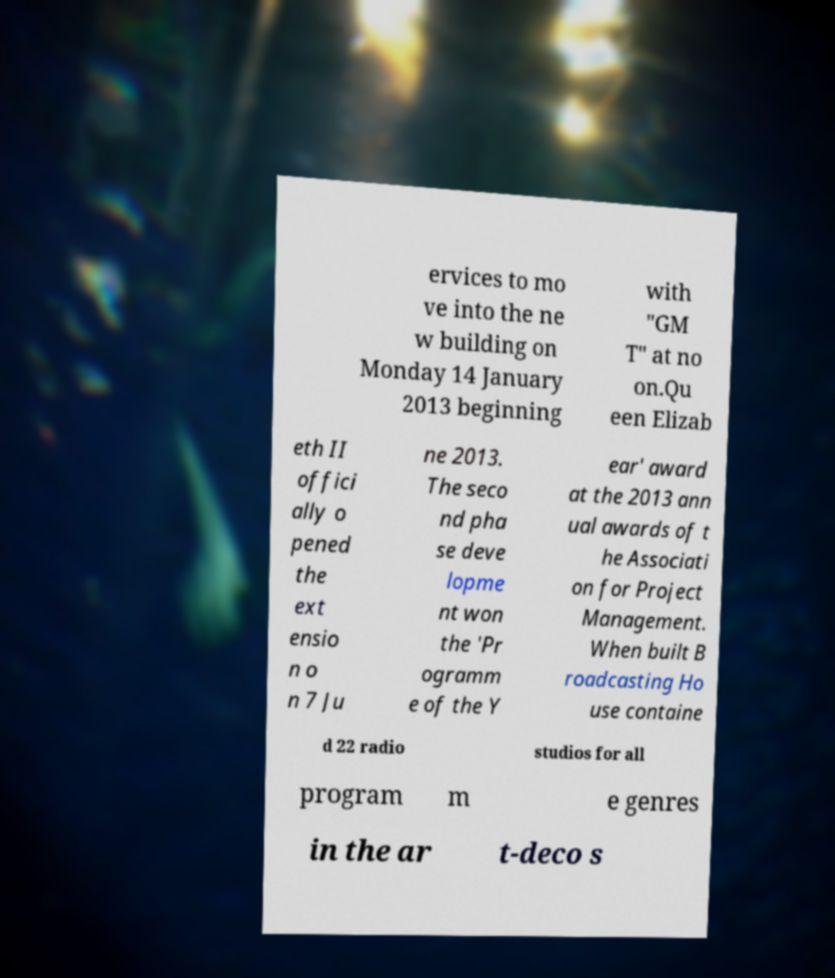I need the written content from this picture converted into text. Can you do that? ervices to mo ve into the ne w building on Monday 14 January 2013 beginning with "GM T" at no on.Qu een Elizab eth II offici ally o pened the ext ensio n o n 7 Ju ne 2013. The seco nd pha se deve lopme nt won the 'Pr ogramm e of the Y ear' award at the 2013 ann ual awards of t he Associati on for Project Management. When built B roadcasting Ho use containe d 22 radio studios for all program m e genres in the ar t-deco s 